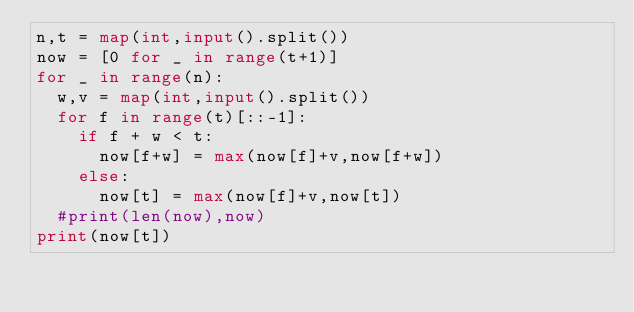<code> <loc_0><loc_0><loc_500><loc_500><_Python_>n,t = map(int,input().split())
now = [0 for _ in range(t+1)]
for _ in range(n):
  w,v = map(int,input().split())
  for f in range(t)[::-1]:
    if f + w < t:
      now[f+w] = max(now[f]+v,now[f+w])
    else:
      now[t] = max(now[f]+v,now[t])
  #print(len(now),now)
print(now[t])</code> 